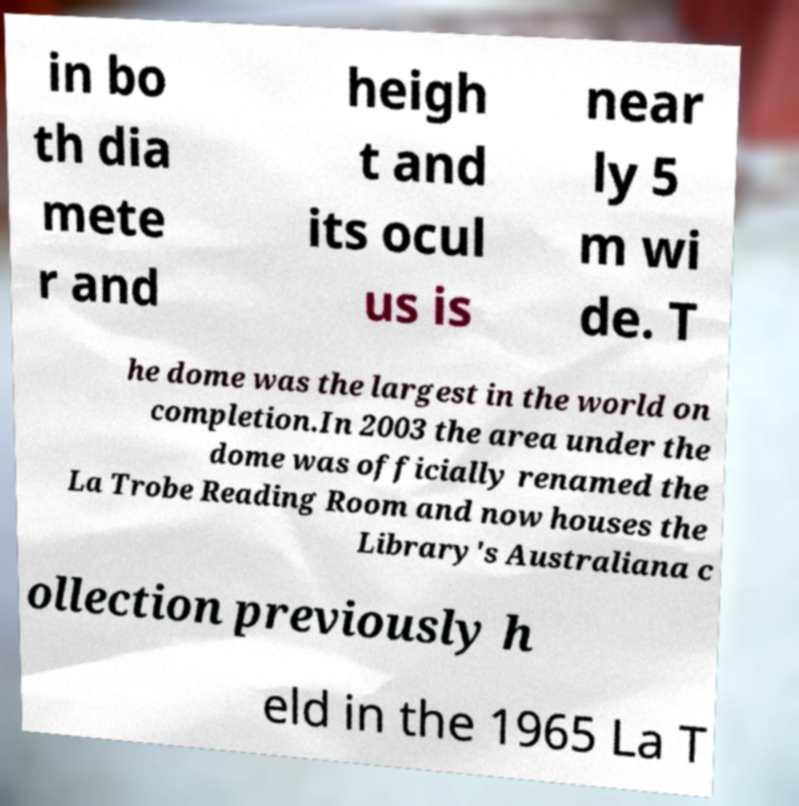Please identify and transcribe the text found in this image. in bo th dia mete r and heigh t and its ocul us is near ly 5 m wi de. T he dome was the largest in the world on completion.In 2003 the area under the dome was officially renamed the La Trobe Reading Room and now houses the Library's Australiana c ollection previously h eld in the 1965 La T 